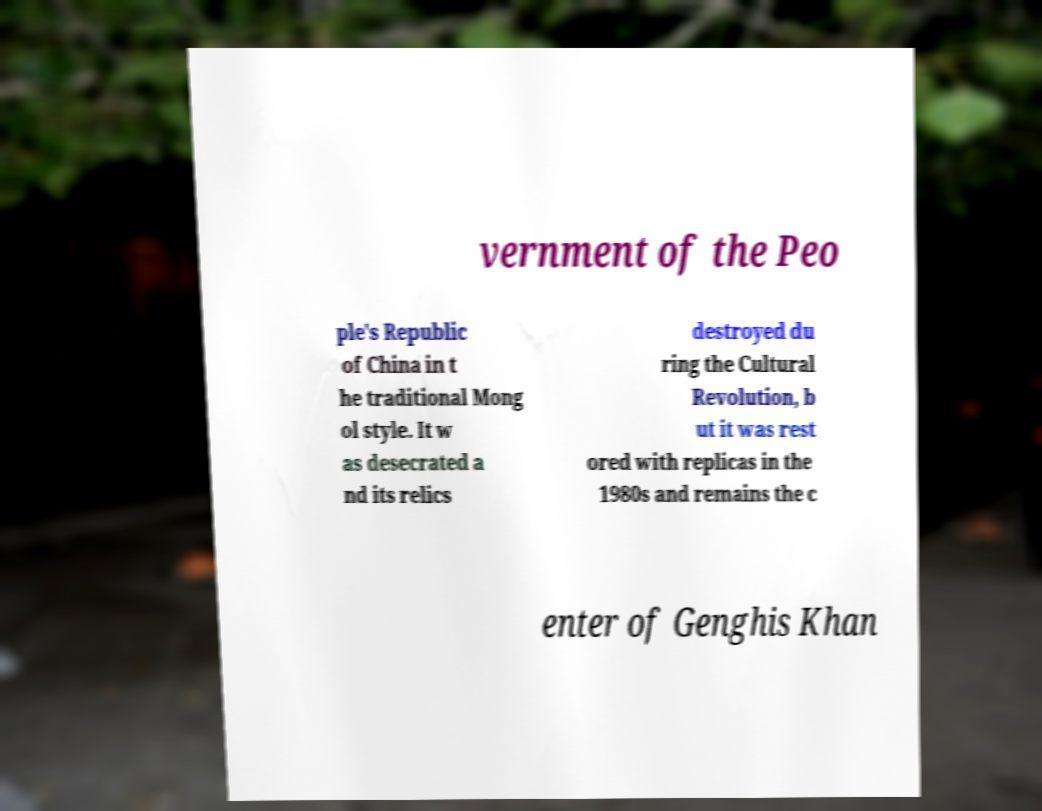There's text embedded in this image that I need extracted. Can you transcribe it verbatim? vernment of the Peo ple's Republic of China in t he traditional Mong ol style. It w as desecrated a nd its relics destroyed du ring the Cultural Revolution, b ut it was rest ored with replicas in the 1980s and remains the c enter of Genghis Khan 